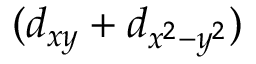Convert formula to latex. <formula><loc_0><loc_0><loc_500><loc_500>( d _ { x y } + d _ { x ^ { 2 } - y ^ { 2 } } )</formula> 